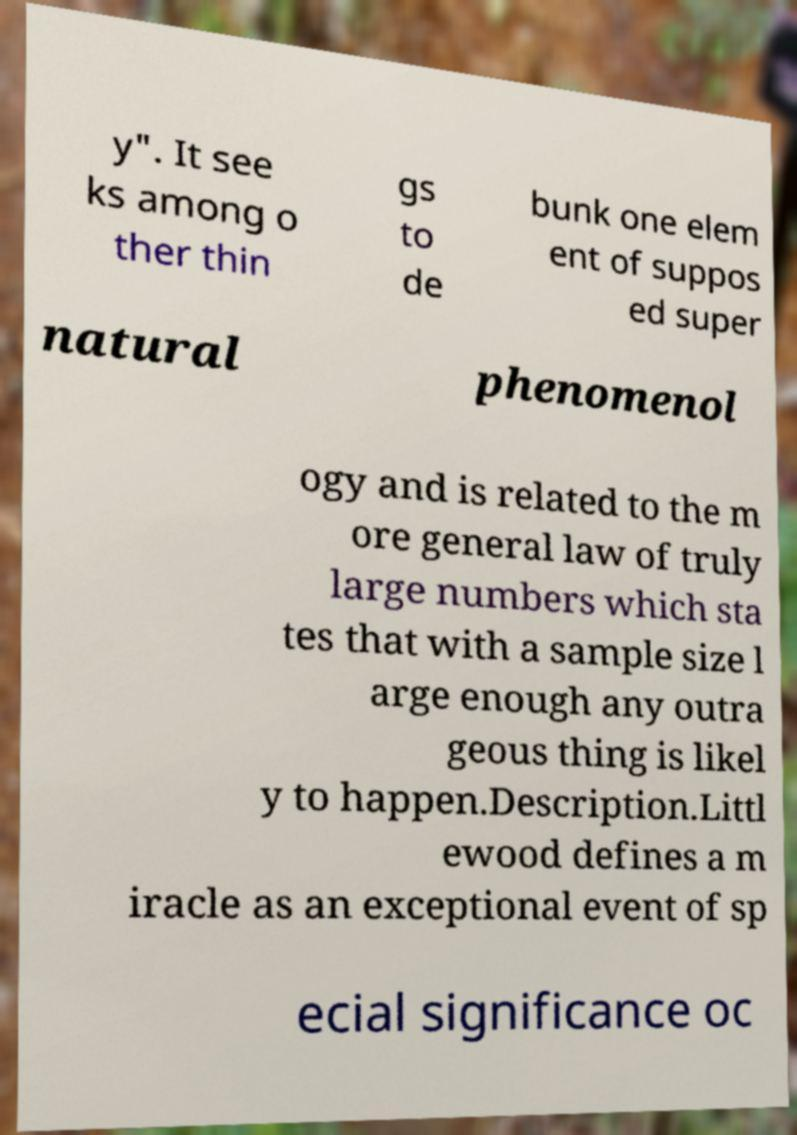Can you accurately transcribe the text from the provided image for me? y". It see ks among o ther thin gs to de bunk one elem ent of suppos ed super natural phenomenol ogy and is related to the m ore general law of truly large numbers which sta tes that with a sample size l arge enough any outra geous thing is likel y to happen.Description.Littl ewood defines a m iracle as an exceptional event of sp ecial significance oc 